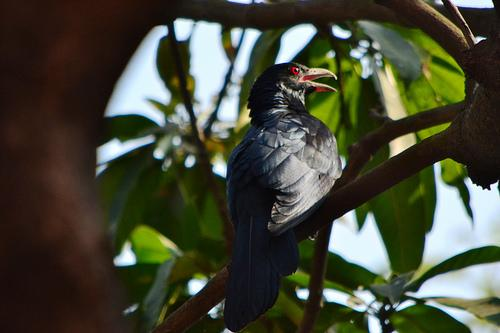What is the color of the bird's feathers in the image? The bird's feathers are black. Count the number of green leaves visible in the image. There are 9 green tree leaves visible in the image. What is the dominant mood or sentiment expressed by the image? The dominant mood is calm and peaceful, as it portrays a bird sitting peacefully in nature. Estimate the overall quality of the image based on the sharpness, colors, and composition. The overall image quality is good, with clear details, vivid colors, and well-defined object positions. Briefly describe the scene depicted in the image. The image shows a beautiful black bird with a red eye, sitting on a brown branch in a tree with green leaves and a blue sky background. Determine if the bird is perched on a branch or on the tree trunk. The bird is perched on a branch. What are the colors of the tree elements and the sky in the image? The tree leaves are green, the branch is brown, the trunk is not colored but has coordinates, and the sky is blue. Is there any interaction between the bird and the leaves of the tree? There is no direct interaction between the bird and the leaves, but the bird is sitting on a branch that has green leaves. Examine the bird's facial features and describe them in detail. The bird has a black head, a red eye with a black round pupil, an orange beak, and an open mouth. Locate the squirrel that is climbing the tree trunk with excitement. No, it's not mentioned in the image. 